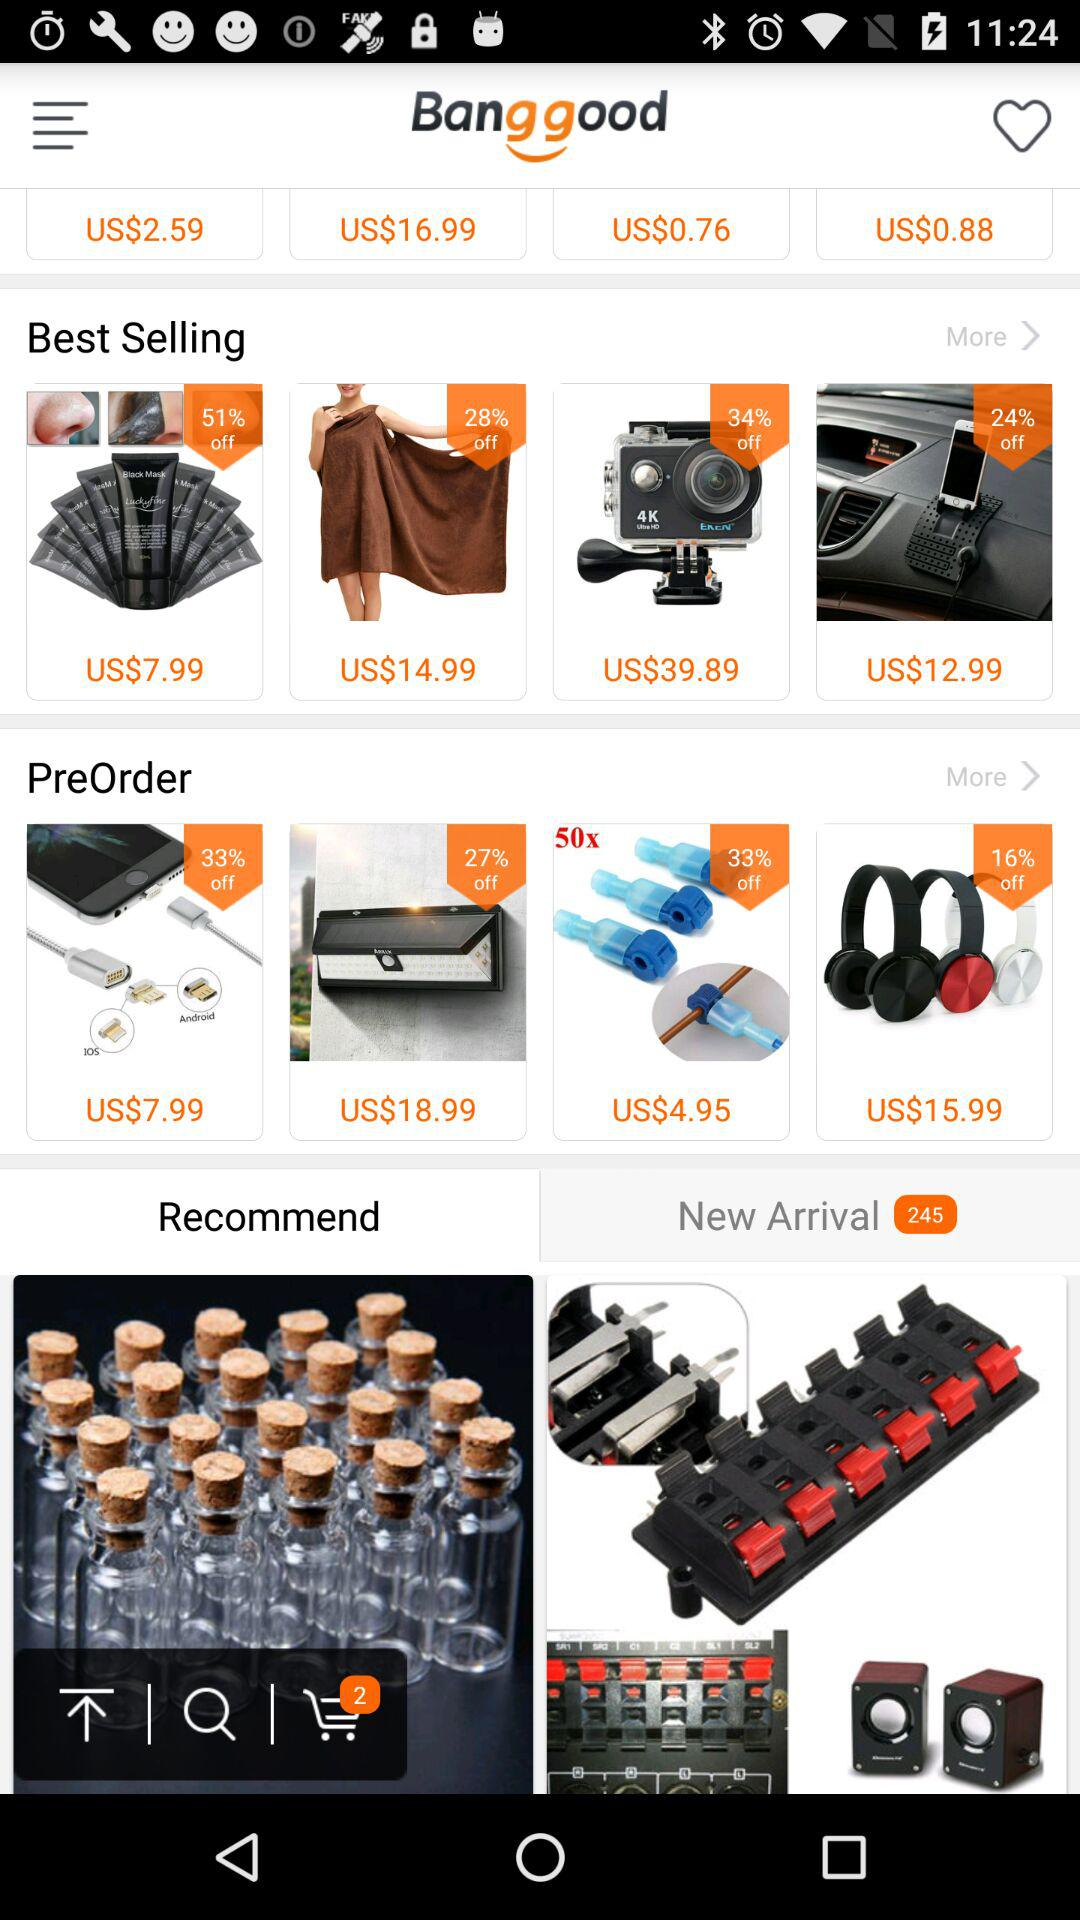Which two items are in the cart?
When the provided information is insufficient, respond with <no answer>. <no answer> 